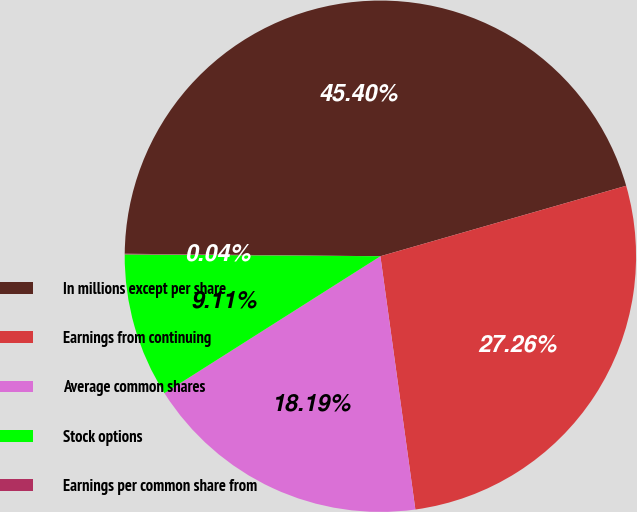<chart> <loc_0><loc_0><loc_500><loc_500><pie_chart><fcel>In millions except per share<fcel>Earnings from continuing<fcel>Average common shares<fcel>Stock options<fcel>Earnings per common share from<nl><fcel>45.4%<fcel>27.26%<fcel>18.19%<fcel>9.11%<fcel>0.04%<nl></chart> 